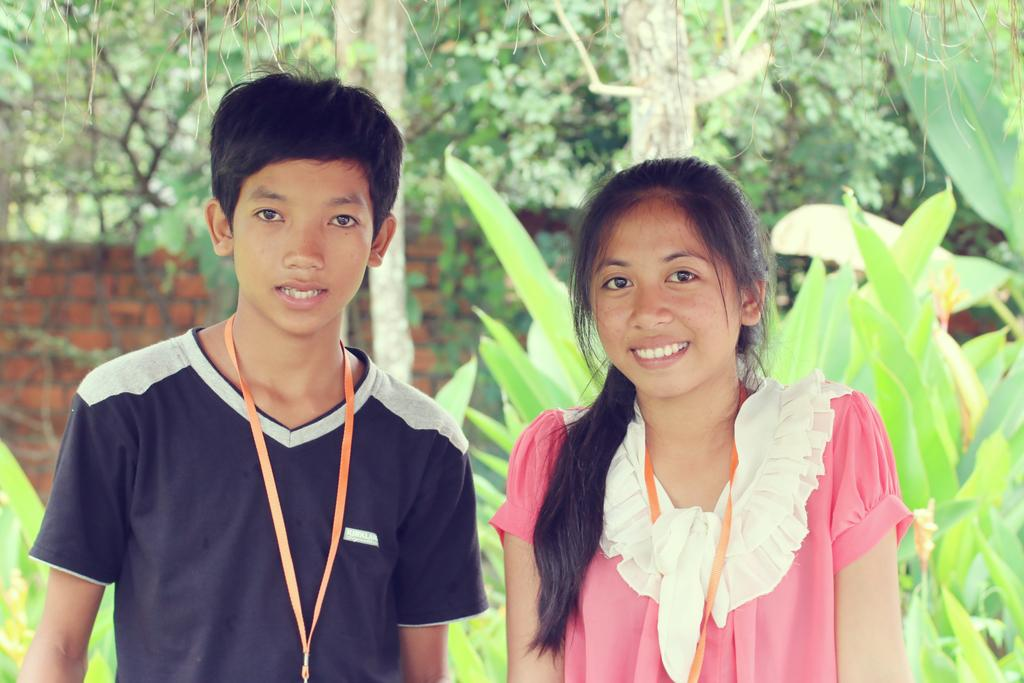What is located on the left side of the image? There is a boy on the left side of the image. What is the boy wearing? The boy is wearing a t-shirt. What is located on the right side of the image? There is a girl on the right side of the image. What is the girl doing in the image? The girl is smiling. What is the girl wearing? The girl is wearing a pink dress. What can be seen in the background of the image? There are trees and a brick wall in the background of the image. What type of property can be seen in the image? There is no property visible in the image. 